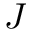<formula> <loc_0><loc_0><loc_500><loc_500>J</formula> 